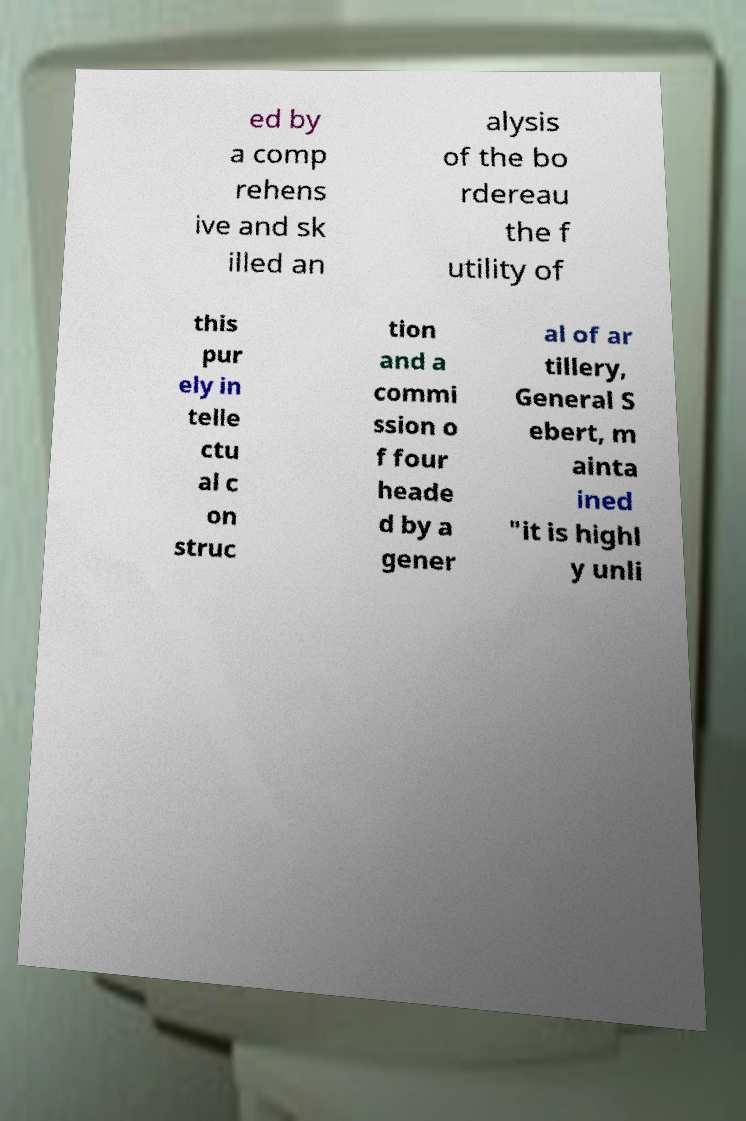Please identify and transcribe the text found in this image. ed by a comp rehens ive and sk illed an alysis of the bo rdereau the f utility of this pur ely in telle ctu al c on struc tion and a commi ssion o f four heade d by a gener al of ar tillery, General S ebert, m ainta ined "it is highl y unli 